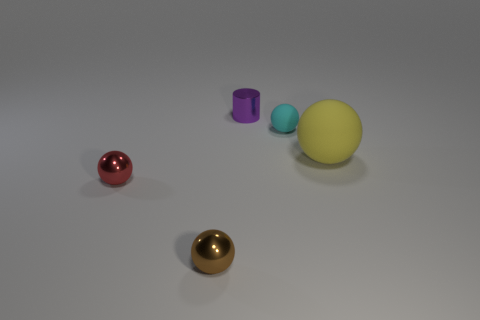Is the number of metallic balls right of the big matte sphere the same as the number of purple things that are in front of the tiny purple cylinder?
Ensure brevity in your answer.  Yes. What is the color of the small sphere that is to the right of the small purple cylinder?
Your response must be concise. Cyan. There is a tiny shiny cylinder; does it have the same color as the tiny metallic ball that is on the right side of the red sphere?
Make the answer very short. No. Are there fewer tiny matte objects than big red objects?
Your response must be concise. No. Is the color of the sphere that is behind the big thing the same as the big thing?
Provide a short and direct response. No. What number of red things are the same size as the cyan object?
Your response must be concise. 1. Are there any big balls that have the same color as the cylinder?
Provide a short and direct response. No. Is the material of the purple cylinder the same as the yellow sphere?
Make the answer very short. No. How many cyan rubber objects are the same shape as the small red shiny thing?
Your answer should be compact. 1. The tiny brown object that is the same material as the purple object is what shape?
Your answer should be very brief. Sphere. 